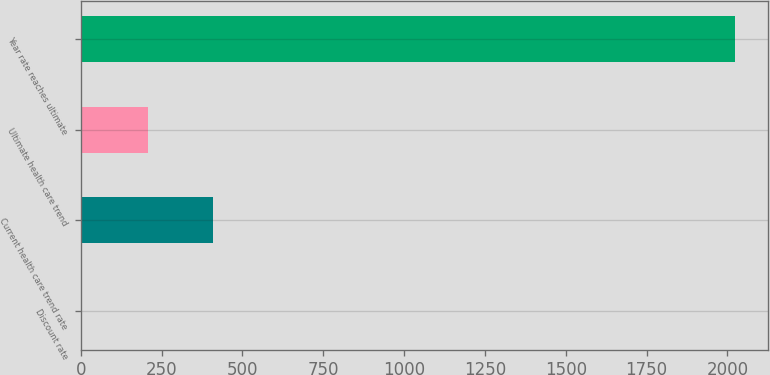<chart> <loc_0><loc_0><loc_500><loc_500><bar_chart><fcel>Discount rate<fcel>Current health care trend rate<fcel>Ultimate health care trend<fcel>Year rate reaches ultimate<nl><fcel>4.6<fcel>408.28<fcel>206.44<fcel>2023<nl></chart> 